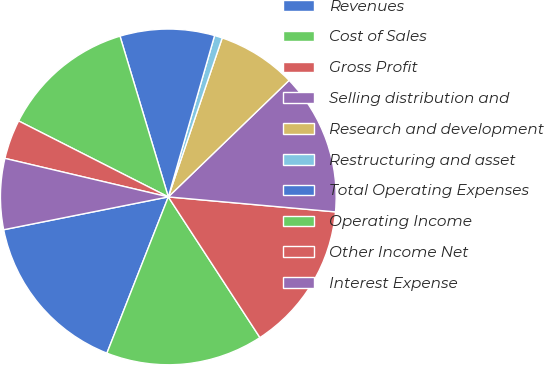Convert chart to OTSL. <chart><loc_0><loc_0><loc_500><loc_500><pie_chart><fcel>Revenues<fcel>Cost of Sales<fcel>Gross Profit<fcel>Selling distribution and<fcel>Research and development<fcel>Restructuring and asset<fcel>Total Operating Expenses<fcel>Operating Income<fcel>Other Income Net<fcel>Interest Expense<nl><fcel>15.91%<fcel>15.15%<fcel>14.39%<fcel>13.64%<fcel>7.58%<fcel>0.76%<fcel>9.09%<fcel>12.88%<fcel>3.79%<fcel>6.82%<nl></chart> 